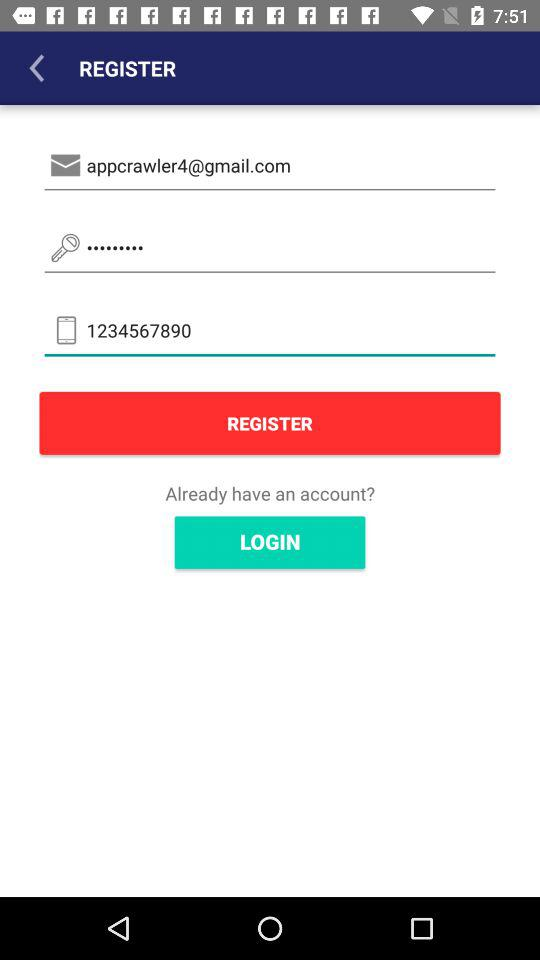What is the mobile number of the user? The mobile number is 1234567890. 